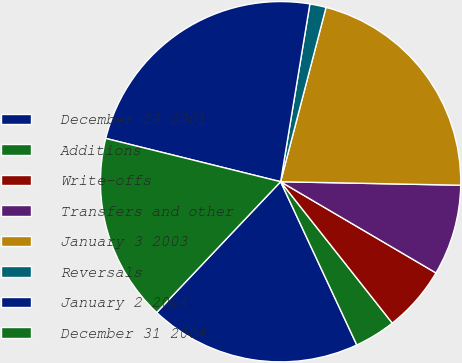Convert chart to OTSL. <chart><loc_0><loc_0><loc_500><loc_500><pie_chart><fcel>December 29 2001<fcel>Additions<fcel>Write-offs<fcel>Transfers and other<fcel>January 3 2003<fcel>Reversals<fcel>January 2 2004<fcel>December 31 2004<nl><fcel>19.02%<fcel>3.69%<fcel>5.91%<fcel>8.14%<fcel>21.25%<fcel>1.46%<fcel>23.73%<fcel>16.79%<nl></chart> 